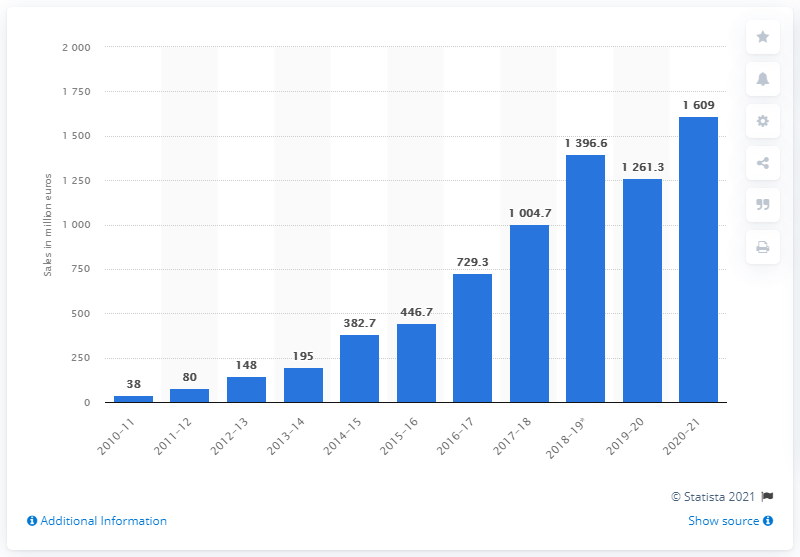Mention a couple of crucial points in this snapshot. In the 2020-2021 fiscal year, Ubisoft generated digital net bookings of approximately 160.9 million US dollars. 